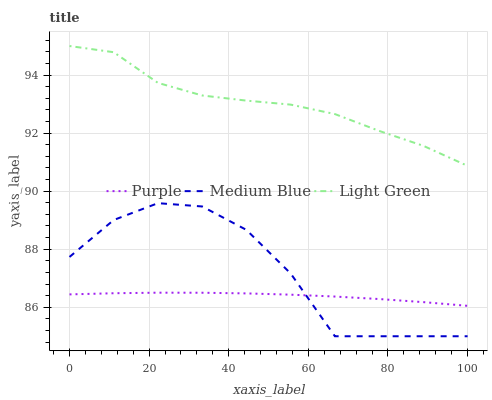Does Purple have the minimum area under the curve?
Answer yes or no. Yes. Does Light Green have the maximum area under the curve?
Answer yes or no. Yes. Does Medium Blue have the minimum area under the curve?
Answer yes or no. No. Does Medium Blue have the maximum area under the curve?
Answer yes or no. No. Is Purple the smoothest?
Answer yes or no. Yes. Is Medium Blue the roughest?
Answer yes or no. Yes. Is Light Green the smoothest?
Answer yes or no. No. Is Light Green the roughest?
Answer yes or no. No. Does Medium Blue have the lowest value?
Answer yes or no. Yes. Does Light Green have the lowest value?
Answer yes or no. No. Does Light Green have the highest value?
Answer yes or no. Yes. Does Medium Blue have the highest value?
Answer yes or no. No. Is Medium Blue less than Light Green?
Answer yes or no. Yes. Is Light Green greater than Medium Blue?
Answer yes or no. Yes. Does Purple intersect Medium Blue?
Answer yes or no. Yes. Is Purple less than Medium Blue?
Answer yes or no. No. Is Purple greater than Medium Blue?
Answer yes or no. No. Does Medium Blue intersect Light Green?
Answer yes or no. No. 